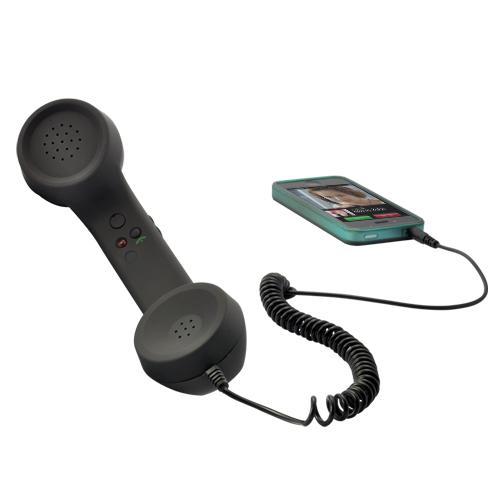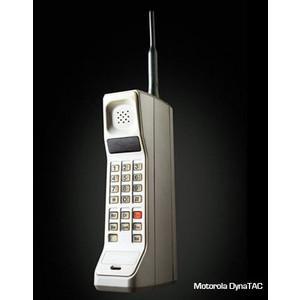The first image is the image on the left, the second image is the image on the right. Given the left and right images, does the statement "There are three objects." hold true? Answer yes or no. Yes. The first image is the image on the left, the second image is the image on the right. Analyze the images presented: Is the assertion "One of the phones is connected to an old fashioned handset." valid? Answer yes or no. Yes. 